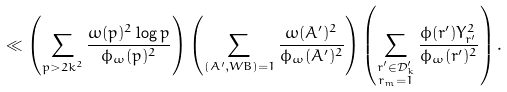<formula> <loc_0><loc_0><loc_500><loc_500>& \ll \left ( \sum _ { p > 2 k ^ { 2 } } \frac { \omega ( p ) ^ { 2 } \log { p } } { \phi _ { \omega } ( p ) ^ { 2 } } \right ) \left ( \sum _ { ( A ^ { \prime } , W B ) = 1 } \frac { \omega ( A ^ { \prime } ) ^ { 2 } } { \phi _ { \omega } ( A ^ { \prime } ) ^ { 2 } } \right ) \left ( \sum _ { \substack { r ^ { \prime } \in \mathcal { D } ^ { \prime } _ { k } \\ r _ { m } = 1 } } \frac { \phi ( r ^ { \prime } ) Y _ { r ^ { \prime } } ^ { 2 } } { \phi _ { \omega } ( r ^ { \prime } ) ^ { 2 } } \right ) .</formula> 